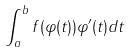Convert formula to latex. <formula><loc_0><loc_0><loc_500><loc_500>\int _ { a } ^ { b } f ( \varphi ( t ) ) \varphi ^ { \prime } ( t ) d t</formula> 